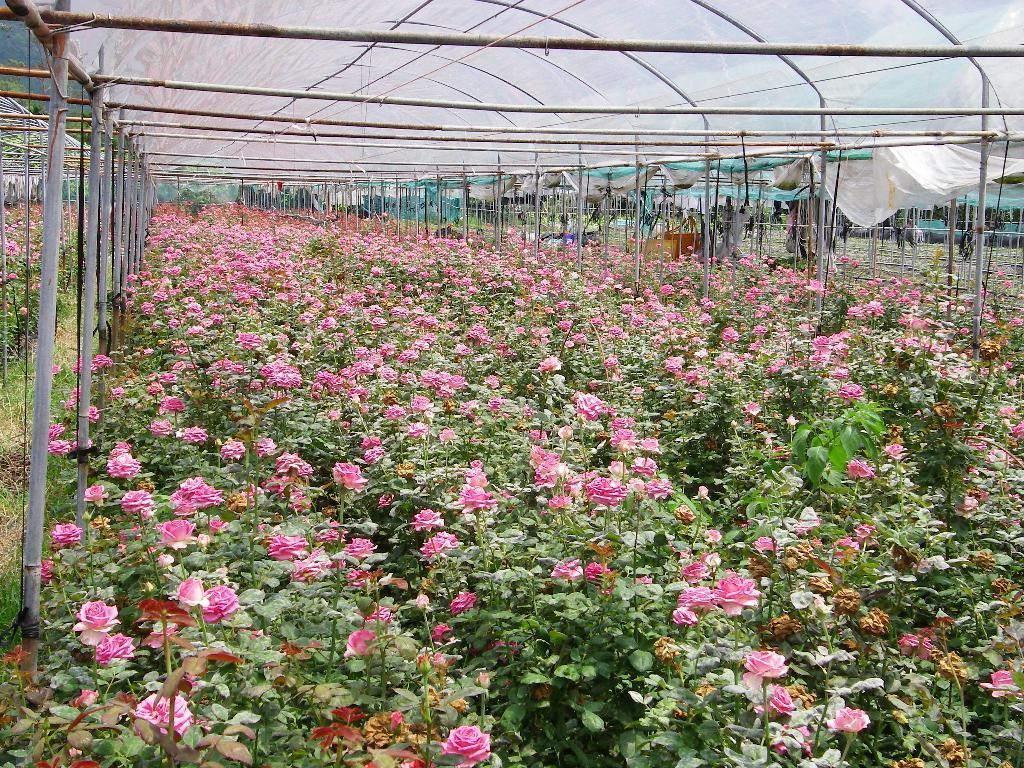Describe this image in one or two sentences. In this picture we can see plants, flowers, sheds and poles. In the background of the image we can see leaves. 